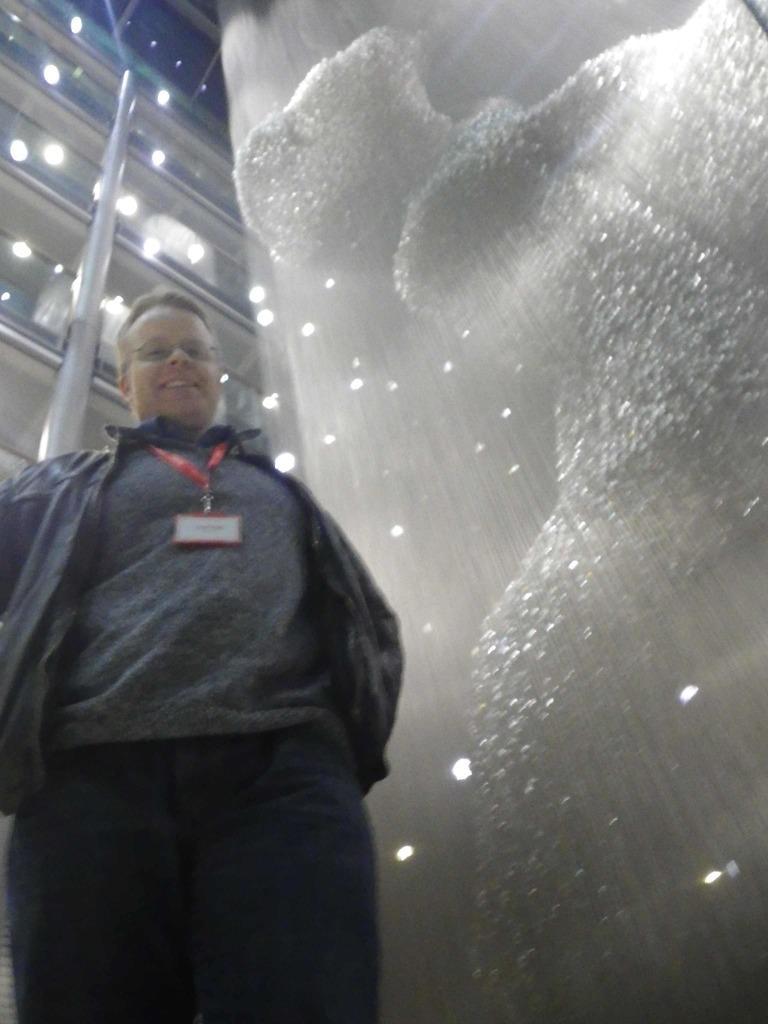Please provide a concise description of this image. On the left there is a person standing, wearing a black jacket and identity card. On the right there is an object in white color. At the top there are lights and railings. 